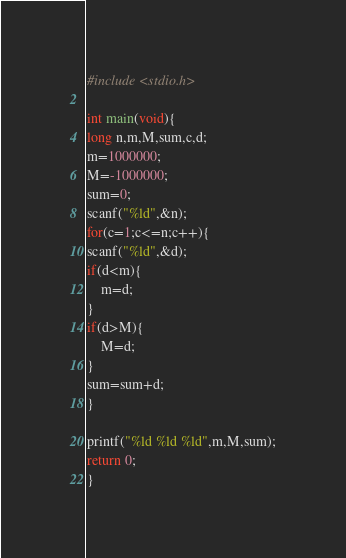<code> <loc_0><loc_0><loc_500><loc_500><_C_>#include <stdio.h>

int main(void){
long n,m,M,sum,c,d;
m=1000000;
M=-1000000;
sum=0;
scanf("%ld",&n);
for(c=1;c<=n;c++){
scanf("%ld",&d);
if(d<m){
	m=d;
}
if(d>M){
	M=d;
}
sum=sum+d;
}

printf("%ld %ld %ld",m,M,sum);
return 0;
}</code> 